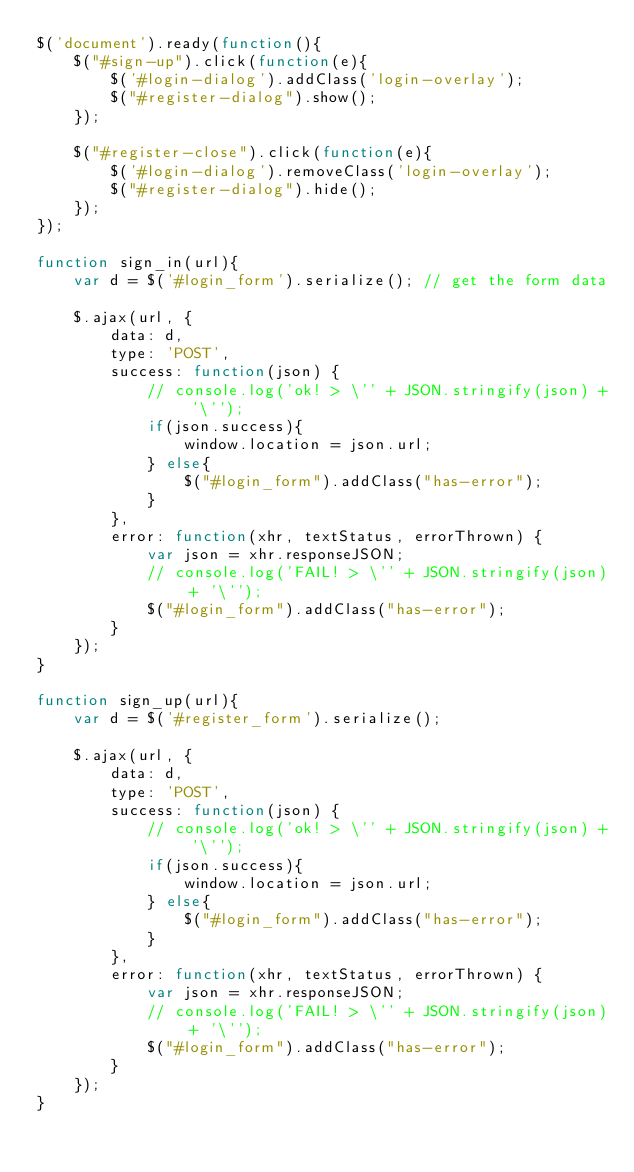Convert code to text. <code><loc_0><loc_0><loc_500><loc_500><_JavaScript_>$('document').ready(function(){
	$("#sign-up").click(function(e){
		$('#login-dialog').addClass('login-overlay');
		$("#register-dialog").show();
	});	
	
	$("#register-close").click(function(e){
		$('#login-dialog').removeClass('login-overlay');
		$("#register-dialog").hide();
	});
});

function sign_in(url){
	var d = $('#login_form').serialize(); // get the form data

	$.ajax(url, {
		data: d,
		type: 'POST',
		success: function(json) {
			// console.log('ok! > \'' + JSON.stringify(json) + '\'');
			if(json.success){
				window.location = json.url;
			} else{
				$("#login_form").addClass("has-error");
			}
		},
		error: function(xhr, textStatus, errorThrown) {
			var json = xhr.responseJSON;
			// console.log('FAIL! > \'' + JSON.stringify(json) + '\'');
			$("#login_form").addClass("has-error");
		}
	});
}

function sign_up(url){
	var d = $('#register_form').serialize();

	$.ajax(url, {
		data: d,
		type: 'POST',
		success: function(json) {
			// console.log('ok! > \'' + JSON.stringify(json) + '\'');
			if(json.success){
				window.location = json.url;
			} else{
				$("#login_form").addClass("has-error");
			}
		},
		error: function(xhr, textStatus, errorThrown) {
			var json = xhr.responseJSON;
			// console.log('FAIL! > \'' + JSON.stringify(json) + '\'');
			$("#login_form").addClass("has-error");
		}
	});
}
</code> 